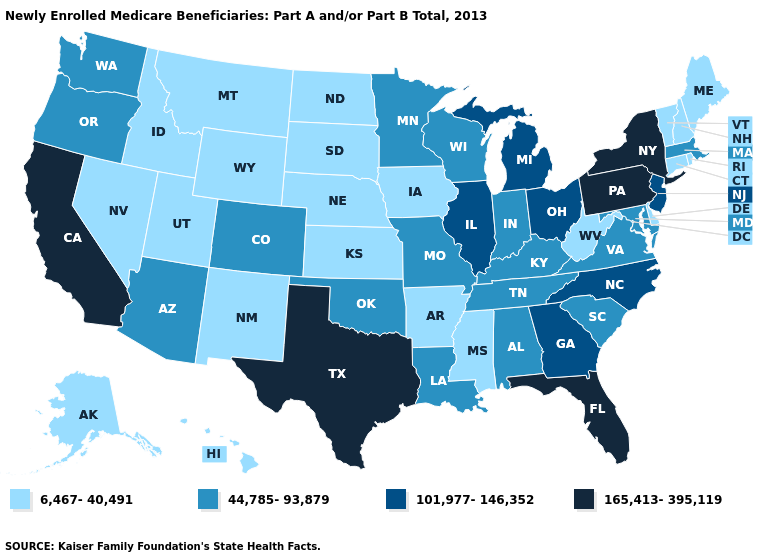Name the states that have a value in the range 6,467-40,491?
Keep it brief. Alaska, Arkansas, Connecticut, Delaware, Hawaii, Idaho, Iowa, Kansas, Maine, Mississippi, Montana, Nebraska, Nevada, New Hampshire, New Mexico, North Dakota, Rhode Island, South Dakota, Utah, Vermont, West Virginia, Wyoming. Which states hav the highest value in the Northeast?
Short answer required. New York, Pennsylvania. What is the value of North Dakota?
Short answer required. 6,467-40,491. Does the map have missing data?
Be succinct. No. Among the states that border Missouri , which have the lowest value?
Give a very brief answer. Arkansas, Iowa, Kansas, Nebraska. What is the lowest value in the West?
Concise answer only. 6,467-40,491. What is the value of Minnesota?
Answer briefly. 44,785-93,879. Does Connecticut have the lowest value in the USA?
Quick response, please. Yes. Which states hav the highest value in the South?
Be succinct. Florida, Texas. Name the states that have a value in the range 101,977-146,352?
Be succinct. Georgia, Illinois, Michigan, New Jersey, North Carolina, Ohio. Name the states that have a value in the range 6,467-40,491?
Give a very brief answer. Alaska, Arkansas, Connecticut, Delaware, Hawaii, Idaho, Iowa, Kansas, Maine, Mississippi, Montana, Nebraska, Nevada, New Hampshire, New Mexico, North Dakota, Rhode Island, South Dakota, Utah, Vermont, West Virginia, Wyoming. How many symbols are there in the legend?
Quick response, please. 4. Which states have the highest value in the USA?
Short answer required. California, Florida, New York, Pennsylvania, Texas. Name the states that have a value in the range 44,785-93,879?
Give a very brief answer. Alabama, Arizona, Colorado, Indiana, Kentucky, Louisiana, Maryland, Massachusetts, Minnesota, Missouri, Oklahoma, Oregon, South Carolina, Tennessee, Virginia, Washington, Wisconsin. 